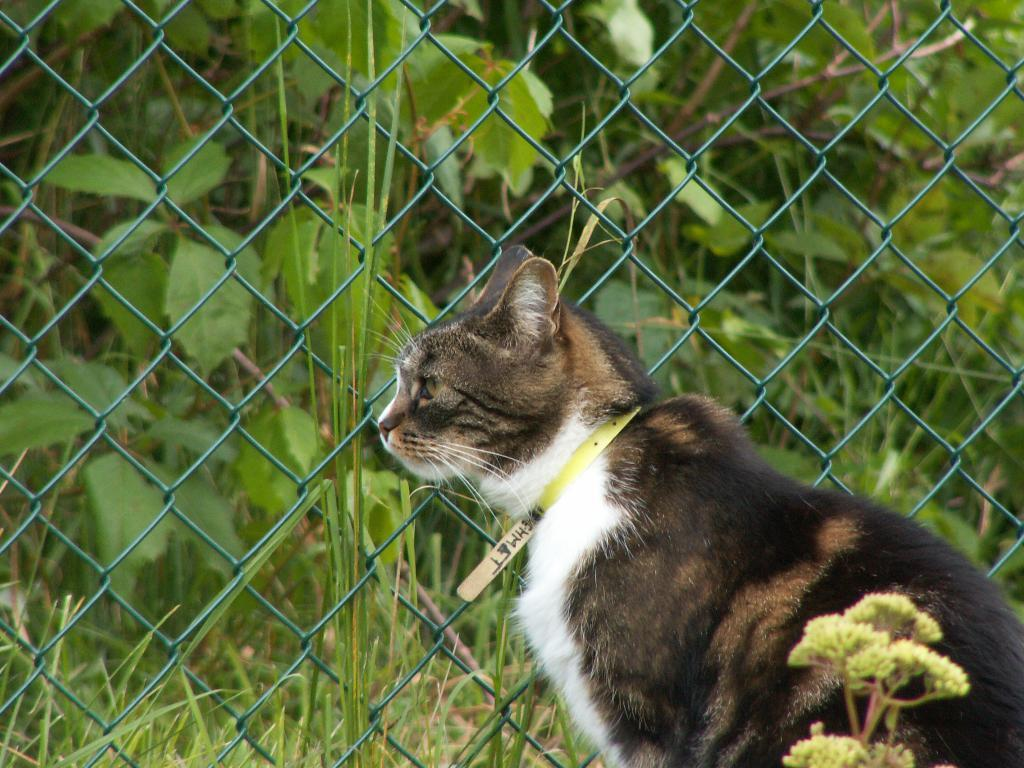What animal is present in the image? There is a cat in the image. What color combination is the cat in? The cat is in black and white color combination. Where is the cat located in relation to the plant? The cat is sitting near a plant. What type of fencing can be seen in the image? There is green color fencing in the image. What is visible outside the fencing? There are plants and grass on the ground outside the fencing. Can you read the letter that the cat is holding in the image? There is no letter present in the image, and the cat is not holding anything. Is there a stream visible in the image? There is no stream present in the image. 